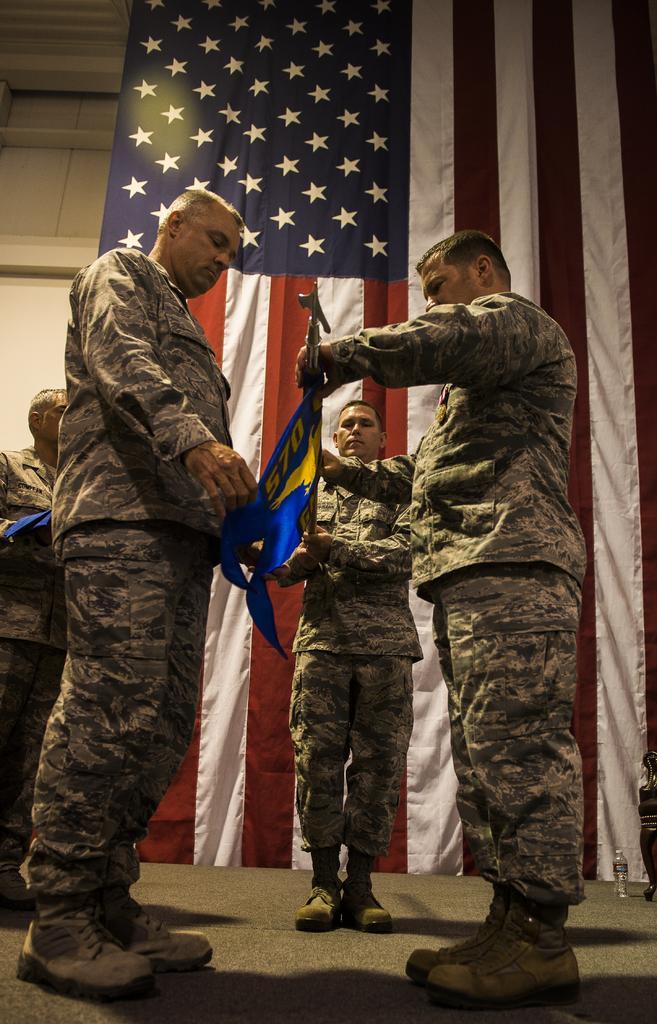How would you summarize this image in a sentence or two? In this picture we can see there are four people standing on the path and the two people are holding an item. Behind the people there is a united states flag and a wall. 